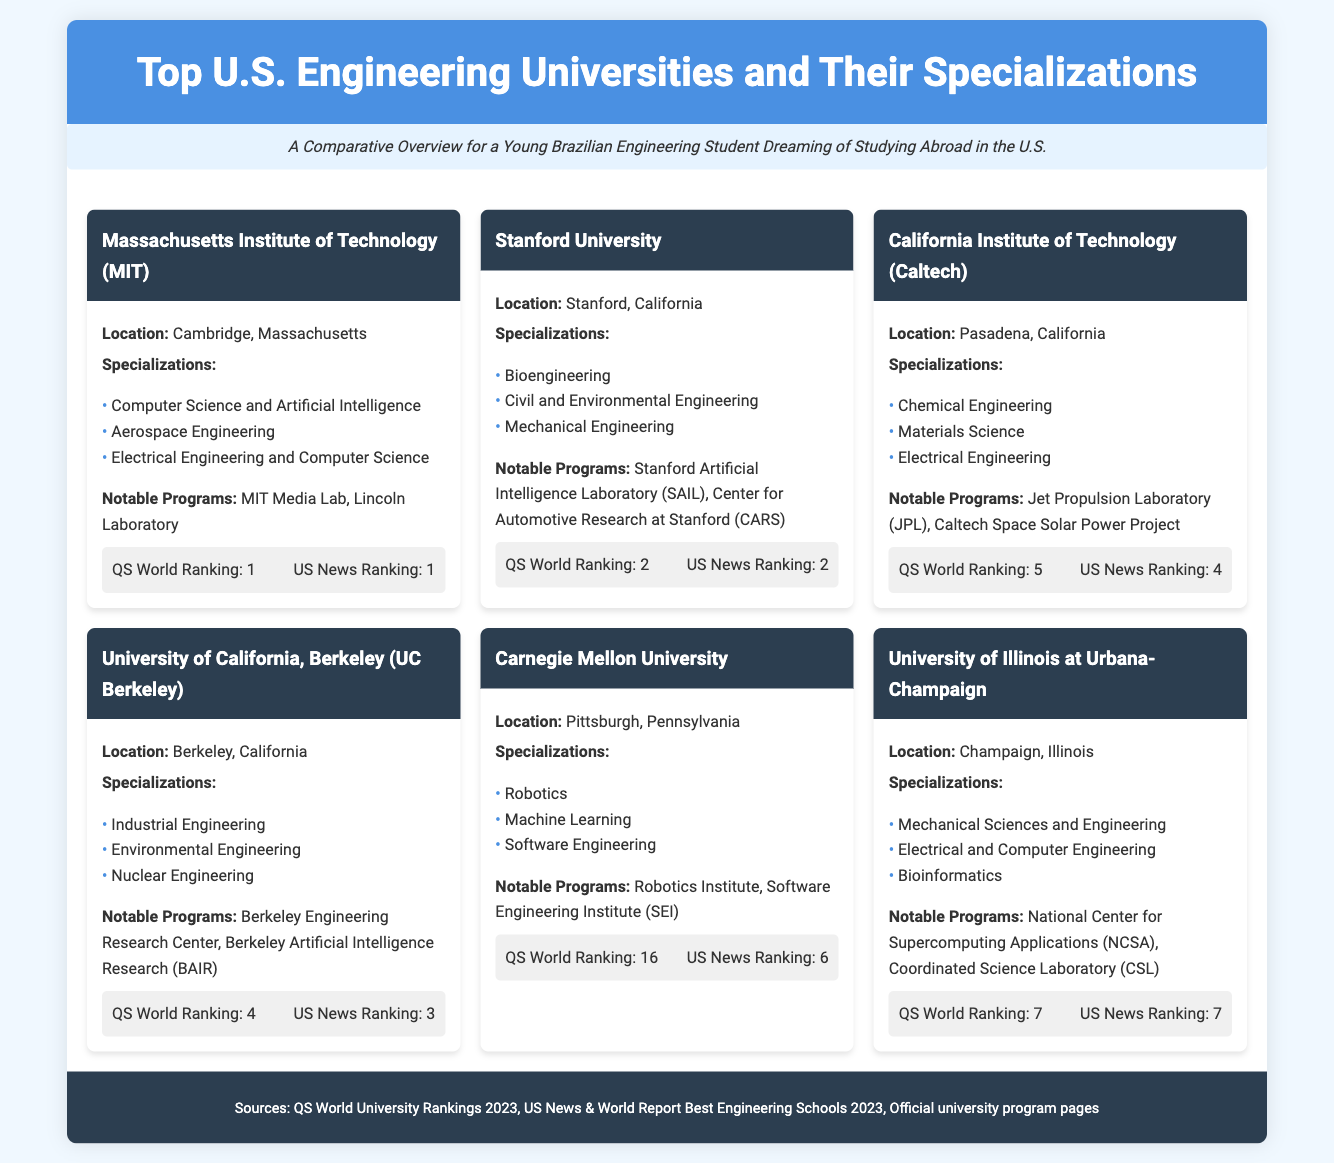What is the top-ranked engineering university according to QS World Ranking? The top-ranked engineering university according to QS World Ranking in the document is Massachusetts Institute of Technology (MIT).
Answer: Massachusetts Institute of Technology (MIT) What unique program is associated with Stanford University? The notable program associated with Stanford University mentioned in the document is the Stanford Artificial Intelligence Laboratory (SAIL).
Answer: Stanford Artificial Intelligence Laboratory (SAIL) Which university specializes in Robotics? The university that specializes in Robotics according to the document is Carnegie Mellon University.
Answer: Carnegie Mellon University What is the US News Ranking for UC Berkeley? The document states that the US News Ranking for University of California, Berkeley is 3.
Answer: 3 How many specializations are listed for Caltech? The document lists three specializations for California Institute of Technology (Caltech).
Answer: Three Which university has a notable program called Jet Propulsion Laboratory? The notable program called Jet Propulsion Laboratory is associated with California Institute of Technology (Caltech).
Answer: California Institute of Technology (Caltech) What location is common to both Stanford University and UC Berkeley? Both Stanford University and University of California, Berkeley are located in California.
Answer: California What is the primary focus of the programs at Massachusetts Institute of Technology? The primary focus of the programs at the Massachusetts Institute of Technology is on Computer Science and Artificial Intelligence.
Answer: Computer Science and Artificial Intelligence 